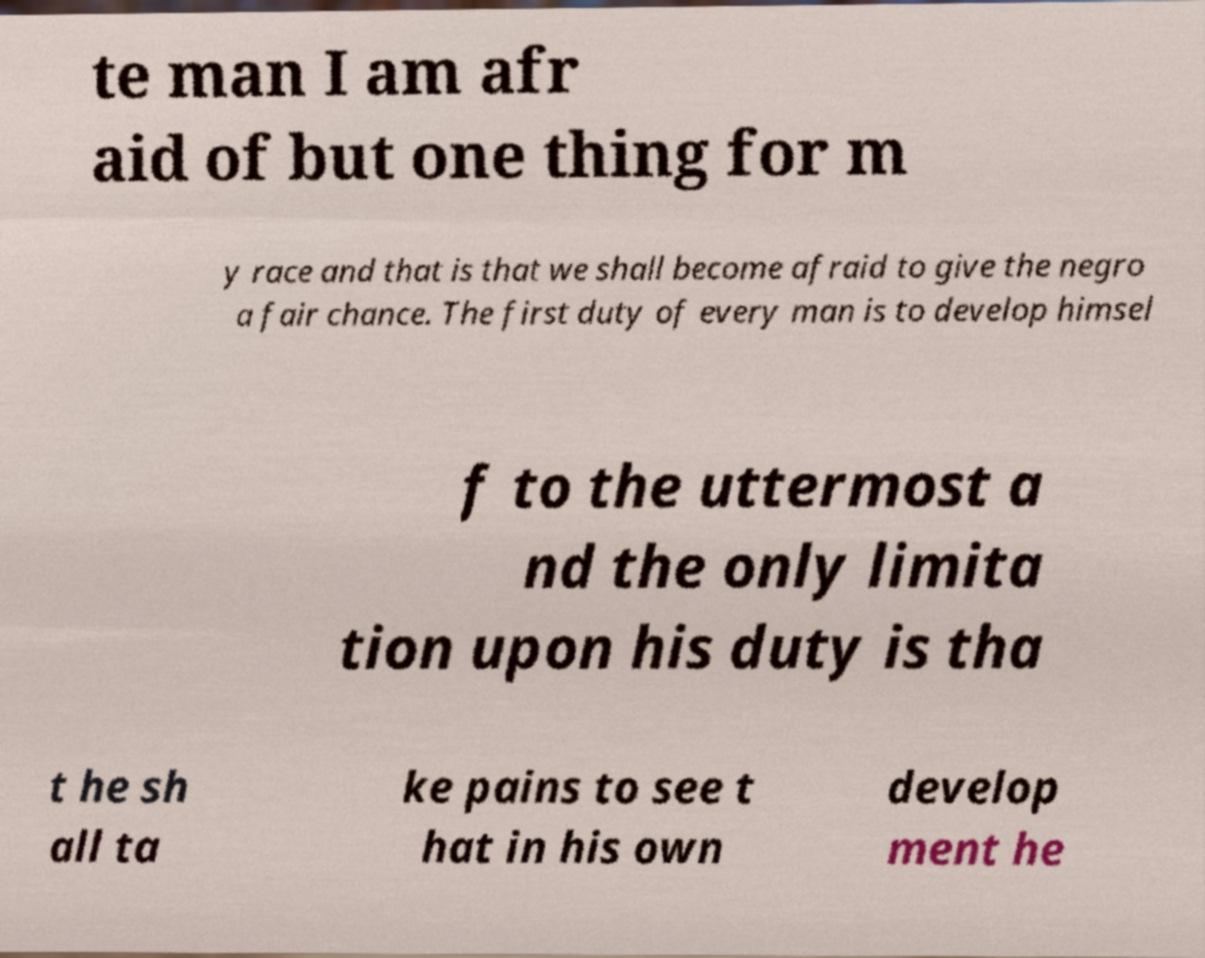Please read and relay the text visible in this image. What does it say? te man I am afr aid of but one thing for m y race and that is that we shall become afraid to give the negro a fair chance. The first duty of every man is to develop himsel f to the uttermost a nd the only limita tion upon his duty is tha t he sh all ta ke pains to see t hat in his own develop ment he 